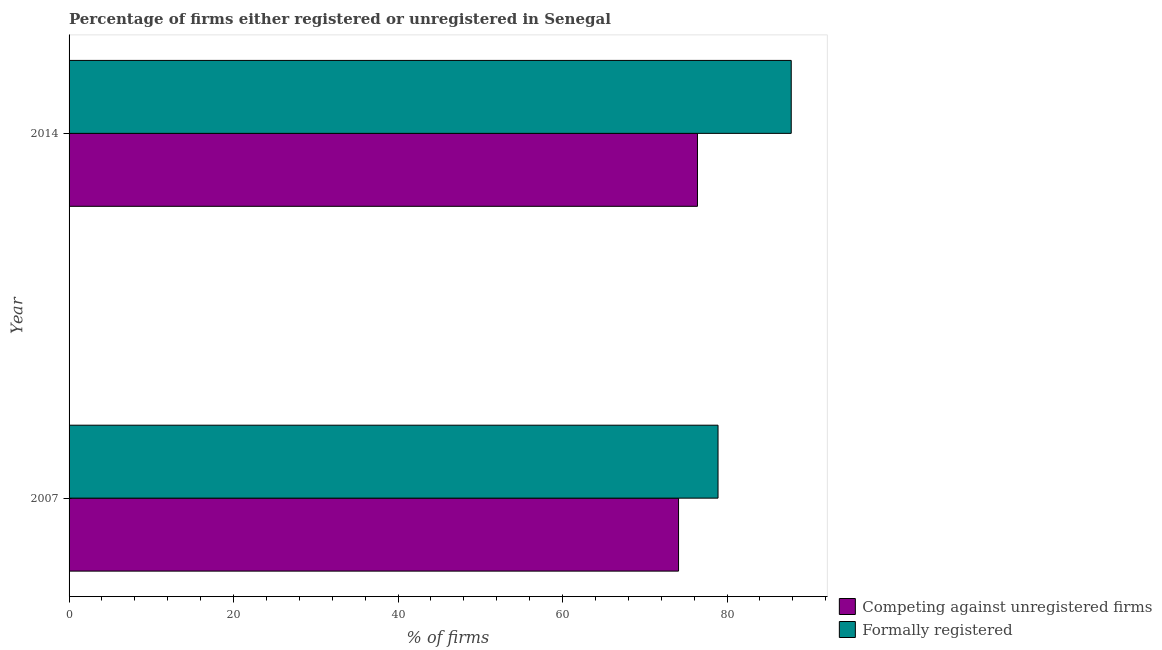How many groups of bars are there?
Give a very brief answer. 2. Are the number of bars on each tick of the Y-axis equal?
Your answer should be very brief. Yes. How many bars are there on the 1st tick from the bottom?
Offer a terse response. 2. What is the percentage of formally registered firms in 2014?
Keep it short and to the point. 87.8. Across all years, what is the maximum percentage of registered firms?
Your answer should be compact. 76.4. Across all years, what is the minimum percentage of registered firms?
Keep it short and to the point. 74.1. In which year was the percentage of registered firms maximum?
Provide a succinct answer. 2014. In which year was the percentage of registered firms minimum?
Your answer should be compact. 2007. What is the total percentage of formally registered firms in the graph?
Provide a succinct answer. 166.7. What is the difference between the percentage of formally registered firms in 2014 and the percentage of registered firms in 2007?
Ensure brevity in your answer.  13.7. What is the average percentage of registered firms per year?
Provide a short and direct response. 75.25. What is the ratio of the percentage of registered firms in 2007 to that in 2014?
Give a very brief answer. 0.97. In how many years, is the percentage of registered firms greater than the average percentage of registered firms taken over all years?
Make the answer very short. 1. What does the 1st bar from the top in 2007 represents?
Your answer should be compact. Formally registered. What does the 2nd bar from the bottom in 2007 represents?
Give a very brief answer. Formally registered. Are all the bars in the graph horizontal?
Your answer should be compact. Yes. How many years are there in the graph?
Your answer should be compact. 2. What is the title of the graph?
Keep it short and to the point. Percentage of firms either registered or unregistered in Senegal. What is the label or title of the X-axis?
Your answer should be compact. % of firms. What is the label or title of the Y-axis?
Ensure brevity in your answer.  Year. What is the % of firms of Competing against unregistered firms in 2007?
Offer a very short reply. 74.1. What is the % of firms of Formally registered in 2007?
Keep it short and to the point. 78.9. What is the % of firms in Competing against unregistered firms in 2014?
Offer a very short reply. 76.4. What is the % of firms of Formally registered in 2014?
Your response must be concise. 87.8. Across all years, what is the maximum % of firms of Competing against unregistered firms?
Ensure brevity in your answer.  76.4. Across all years, what is the maximum % of firms in Formally registered?
Make the answer very short. 87.8. Across all years, what is the minimum % of firms of Competing against unregistered firms?
Provide a succinct answer. 74.1. Across all years, what is the minimum % of firms of Formally registered?
Make the answer very short. 78.9. What is the total % of firms of Competing against unregistered firms in the graph?
Give a very brief answer. 150.5. What is the total % of firms of Formally registered in the graph?
Ensure brevity in your answer.  166.7. What is the difference between the % of firms of Competing against unregistered firms in 2007 and that in 2014?
Provide a short and direct response. -2.3. What is the difference between the % of firms in Formally registered in 2007 and that in 2014?
Provide a succinct answer. -8.9. What is the difference between the % of firms in Competing against unregistered firms in 2007 and the % of firms in Formally registered in 2014?
Keep it short and to the point. -13.7. What is the average % of firms in Competing against unregistered firms per year?
Ensure brevity in your answer.  75.25. What is the average % of firms of Formally registered per year?
Offer a terse response. 83.35. In the year 2007, what is the difference between the % of firms in Competing against unregistered firms and % of firms in Formally registered?
Provide a succinct answer. -4.8. In the year 2014, what is the difference between the % of firms of Competing against unregistered firms and % of firms of Formally registered?
Provide a short and direct response. -11.4. What is the ratio of the % of firms in Competing against unregistered firms in 2007 to that in 2014?
Your response must be concise. 0.97. What is the ratio of the % of firms in Formally registered in 2007 to that in 2014?
Make the answer very short. 0.9. What is the difference between the highest and the second highest % of firms in Competing against unregistered firms?
Your answer should be very brief. 2.3. What is the difference between the highest and the second highest % of firms of Formally registered?
Your answer should be very brief. 8.9. What is the difference between the highest and the lowest % of firms of Competing against unregistered firms?
Give a very brief answer. 2.3. What is the difference between the highest and the lowest % of firms of Formally registered?
Your answer should be very brief. 8.9. 